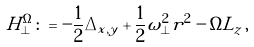<formula> <loc_0><loc_0><loc_500><loc_500>H ^ { \Omega } _ { \perp } \colon = - \frac { 1 } { 2 } \Delta _ { x , y } + \frac { 1 } { 2 } \omega _ { \perp } ^ { 2 } r ^ { 2 } - \Omega L _ { z } \, ,</formula> 